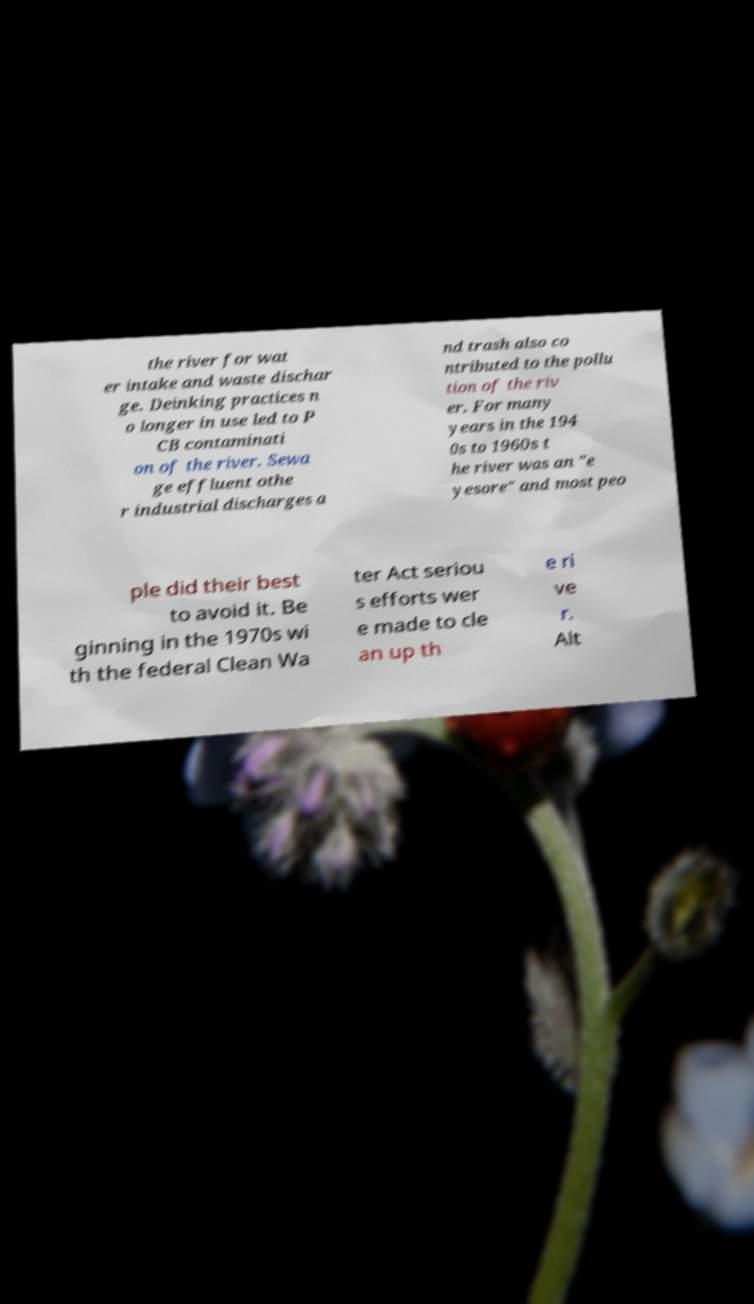Could you extract and type out the text from this image? the river for wat er intake and waste dischar ge. Deinking practices n o longer in use led to P CB contaminati on of the river. Sewa ge effluent othe r industrial discharges a nd trash also co ntributed to the pollu tion of the riv er. For many years in the 194 0s to 1960s t he river was an "e yesore" and most peo ple did their best to avoid it. Be ginning in the 1970s wi th the federal Clean Wa ter Act seriou s efforts wer e made to cle an up th e ri ve r. Alt 